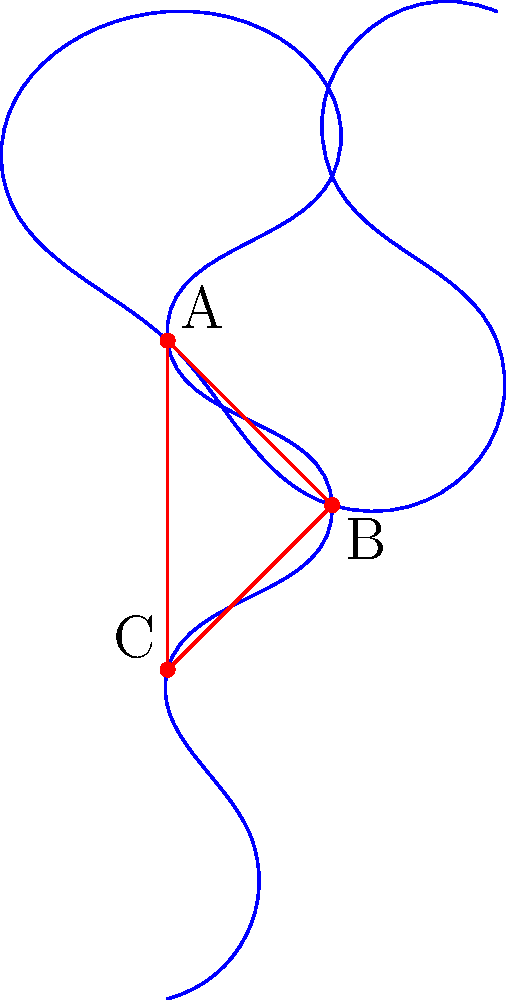In the stylized treble clef symbol shown, points A, B, and C form a triangle. Given that the angle at point B is 60°, and the distance from A to C is 4 units, what is the area of triangle ABC? To solve this problem, we'll use the following steps:

1) First, we recognize that we're dealing with a triangle where we know one angle (60° at B) and the length of the opposite side (AC = 4 units).

2) This scenario is perfect for applying the formula for the area of a triangle using sine:

   Area = $\frac{1}{2} \cdot ab \cdot \sin(C)$

   Where a and b are two sides of the triangle, and C is the angle between them.

3) We know AC (let's call it c) = 4 units, and angle B = 60°. We need to use these in our formula.

4) The sine formula for area can be rearranged to:

   Area = $\frac{1}{2} \cdot c^2 \cdot \sin(B)$

5) Now we can plug in our known values:

   Area = $\frac{1}{2} \cdot 4^2 \cdot \sin(60°)$

6) Simplify:
   Area = $\frac{1}{2} \cdot 16 \cdot \frac{\sqrt{3}}{2}$

7) Calculate:
   Area = $8 \cdot \frac{\sqrt{3}}{2} = 4\sqrt{3}$

Therefore, the area of the triangle is $4\sqrt{3}$ square units.
Answer: $4\sqrt{3}$ square units 